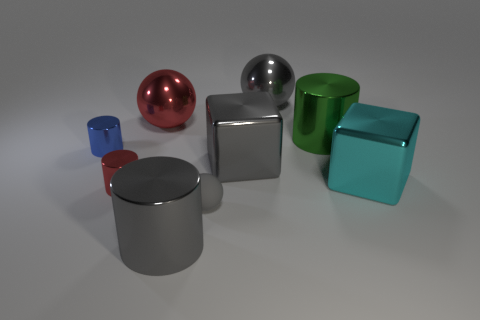Subtract 1 balls. How many balls are left? 2 Subtract all green cylinders. How many cylinders are left? 3 Subtract all blue cylinders. How many cylinders are left? 3 Add 1 small blue metal cylinders. How many objects exist? 10 Subtract all purple cylinders. Subtract all brown blocks. How many cylinders are left? 4 Subtract all blocks. How many objects are left? 7 Add 2 gray blocks. How many gray blocks are left? 3 Add 9 blue shiny things. How many blue shiny things exist? 10 Subtract 1 red cylinders. How many objects are left? 8 Subtract all green metallic cylinders. Subtract all small gray things. How many objects are left? 7 